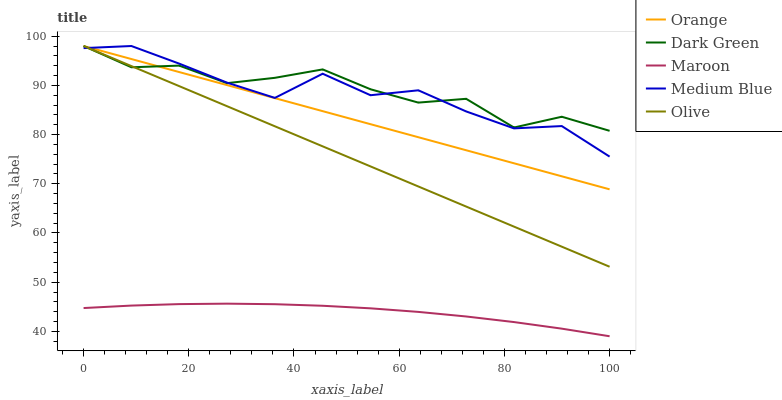Does Maroon have the minimum area under the curve?
Answer yes or no. Yes. Does Dark Green have the maximum area under the curve?
Answer yes or no. Yes. Does Olive have the minimum area under the curve?
Answer yes or no. No. Does Olive have the maximum area under the curve?
Answer yes or no. No. Is Olive the smoothest?
Answer yes or no. Yes. Is Medium Blue the roughest?
Answer yes or no. Yes. Is Medium Blue the smoothest?
Answer yes or no. No. Is Olive the roughest?
Answer yes or no. No. Does Olive have the lowest value?
Answer yes or no. No. Does Maroon have the highest value?
Answer yes or no. No. Is Maroon less than Medium Blue?
Answer yes or no. Yes. Is Medium Blue greater than Maroon?
Answer yes or no. Yes. Does Maroon intersect Medium Blue?
Answer yes or no. No. 